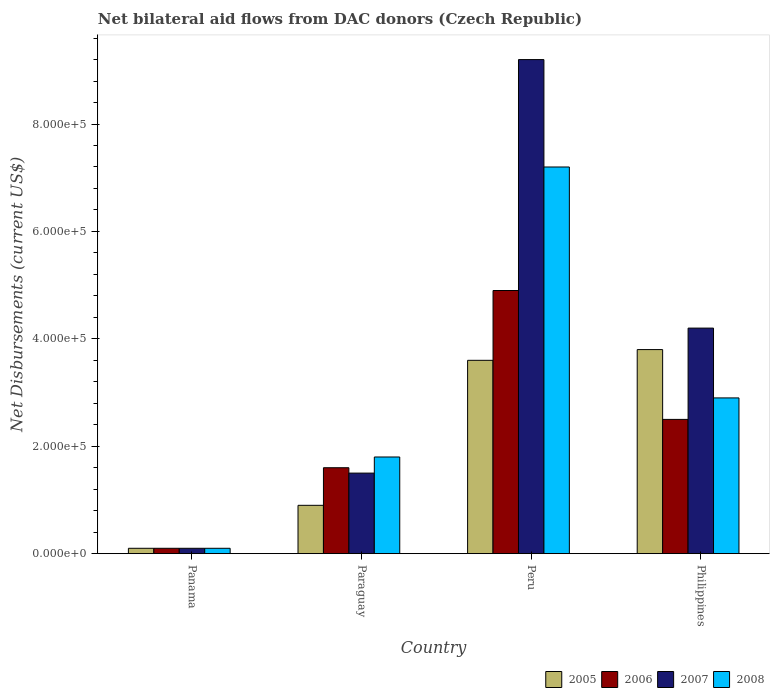How many groups of bars are there?
Give a very brief answer. 4. Are the number of bars per tick equal to the number of legend labels?
Your answer should be very brief. Yes. Are the number of bars on each tick of the X-axis equal?
Your answer should be very brief. Yes. How many bars are there on the 1st tick from the left?
Your answer should be very brief. 4. What is the label of the 3rd group of bars from the left?
Make the answer very short. Peru. In how many cases, is the number of bars for a given country not equal to the number of legend labels?
Offer a very short reply. 0. Across all countries, what is the maximum net bilateral aid flows in 2007?
Provide a succinct answer. 9.20e+05. In which country was the net bilateral aid flows in 2008 maximum?
Your answer should be compact. Peru. In which country was the net bilateral aid flows in 2007 minimum?
Offer a terse response. Panama. What is the total net bilateral aid flows in 2005 in the graph?
Ensure brevity in your answer.  8.40e+05. What is the difference between the net bilateral aid flows of/in 2006 and net bilateral aid flows of/in 2008 in Peru?
Your answer should be very brief. -2.30e+05. What is the ratio of the net bilateral aid flows in 2005 in Panama to that in Philippines?
Make the answer very short. 0.03. Is the difference between the net bilateral aid flows in 2006 in Panama and Philippines greater than the difference between the net bilateral aid flows in 2008 in Panama and Philippines?
Provide a succinct answer. Yes. What is the difference between the highest and the lowest net bilateral aid flows in 2008?
Your response must be concise. 7.10e+05. Is the sum of the net bilateral aid flows in 2005 in Peru and Philippines greater than the maximum net bilateral aid flows in 2008 across all countries?
Ensure brevity in your answer.  Yes. Is it the case that in every country, the sum of the net bilateral aid flows in 2005 and net bilateral aid flows in 2008 is greater than the sum of net bilateral aid flows in 2006 and net bilateral aid flows in 2007?
Your answer should be compact. No. What does the 1st bar from the left in Peru represents?
Provide a succinct answer. 2005. What does the 4th bar from the right in Philippines represents?
Your answer should be compact. 2005. How many bars are there?
Offer a very short reply. 16. Are all the bars in the graph horizontal?
Keep it short and to the point. No. How many countries are there in the graph?
Your answer should be compact. 4. Does the graph contain grids?
Provide a succinct answer. No. How many legend labels are there?
Offer a terse response. 4. How are the legend labels stacked?
Keep it short and to the point. Horizontal. What is the title of the graph?
Make the answer very short. Net bilateral aid flows from DAC donors (Czech Republic). Does "2006" appear as one of the legend labels in the graph?
Ensure brevity in your answer.  Yes. What is the label or title of the X-axis?
Provide a succinct answer. Country. What is the label or title of the Y-axis?
Provide a succinct answer. Net Disbursements (current US$). What is the Net Disbursements (current US$) of 2007 in Panama?
Make the answer very short. 10000. What is the Net Disbursements (current US$) of 2006 in Paraguay?
Offer a terse response. 1.60e+05. What is the Net Disbursements (current US$) in 2008 in Paraguay?
Give a very brief answer. 1.80e+05. What is the Net Disbursements (current US$) in 2007 in Peru?
Your answer should be very brief. 9.20e+05. What is the Net Disbursements (current US$) of 2008 in Peru?
Ensure brevity in your answer.  7.20e+05. What is the Net Disbursements (current US$) in 2005 in Philippines?
Make the answer very short. 3.80e+05. What is the Net Disbursements (current US$) in 2007 in Philippines?
Your response must be concise. 4.20e+05. Across all countries, what is the maximum Net Disbursements (current US$) in 2007?
Your answer should be compact. 9.20e+05. Across all countries, what is the maximum Net Disbursements (current US$) in 2008?
Your response must be concise. 7.20e+05. Across all countries, what is the minimum Net Disbursements (current US$) of 2006?
Make the answer very short. 10000. Across all countries, what is the minimum Net Disbursements (current US$) in 2008?
Give a very brief answer. 10000. What is the total Net Disbursements (current US$) in 2005 in the graph?
Your answer should be compact. 8.40e+05. What is the total Net Disbursements (current US$) of 2006 in the graph?
Ensure brevity in your answer.  9.10e+05. What is the total Net Disbursements (current US$) of 2007 in the graph?
Provide a short and direct response. 1.50e+06. What is the total Net Disbursements (current US$) of 2008 in the graph?
Offer a very short reply. 1.20e+06. What is the difference between the Net Disbursements (current US$) in 2005 in Panama and that in Paraguay?
Offer a terse response. -8.00e+04. What is the difference between the Net Disbursements (current US$) in 2006 in Panama and that in Paraguay?
Your answer should be compact. -1.50e+05. What is the difference between the Net Disbursements (current US$) in 2005 in Panama and that in Peru?
Your answer should be very brief. -3.50e+05. What is the difference between the Net Disbursements (current US$) in 2006 in Panama and that in Peru?
Your response must be concise. -4.80e+05. What is the difference between the Net Disbursements (current US$) in 2007 in Panama and that in Peru?
Your answer should be compact. -9.10e+05. What is the difference between the Net Disbursements (current US$) of 2008 in Panama and that in Peru?
Provide a short and direct response. -7.10e+05. What is the difference between the Net Disbursements (current US$) of 2005 in Panama and that in Philippines?
Offer a terse response. -3.70e+05. What is the difference between the Net Disbursements (current US$) in 2007 in Panama and that in Philippines?
Offer a very short reply. -4.10e+05. What is the difference between the Net Disbursements (current US$) of 2008 in Panama and that in Philippines?
Give a very brief answer. -2.80e+05. What is the difference between the Net Disbursements (current US$) in 2005 in Paraguay and that in Peru?
Offer a very short reply. -2.70e+05. What is the difference between the Net Disbursements (current US$) in 2006 in Paraguay and that in Peru?
Provide a succinct answer. -3.30e+05. What is the difference between the Net Disbursements (current US$) of 2007 in Paraguay and that in Peru?
Provide a succinct answer. -7.70e+05. What is the difference between the Net Disbursements (current US$) in 2008 in Paraguay and that in Peru?
Your answer should be compact. -5.40e+05. What is the difference between the Net Disbursements (current US$) in 2005 in Paraguay and that in Philippines?
Ensure brevity in your answer.  -2.90e+05. What is the difference between the Net Disbursements (current US$) in 2007 in Paraguay and that in Philippines?
Provide a succinct answer. -2.70e+05. What is the difference between the Net Disbursements (current US$) in 2008 in Paraguay and that in Philippines?
Keep it short and to the point. -1.10e+05. What is the difference between the Net Disbursements (current US$) of 2005 in Peru and that in Philippines?
Your answer should be compact. -2.00e+04. What is the difference between the Net Disbursements (current US$) of 2008 in Peru and that in Philippines?
Ensure brevity in your answer.  4.30e+05. What is the difference between the Net Disbursements (current US$) in 2005 in Panama and the Net Disbursements (current US$) in 2006 in Peru?
Provide a short and direct response. -4.80e+05. What is the difference between the Net Disbursements (current US$) in 2005 in Panama and the Net Disbursements (current US$) in 2007 in Peru?
Make the answer very short. -9.10e+05. What is the difference between the Net Disbursements (current US$) of 2005 in Panama and the Net Disbursements (current US$) of 2008 in Peru?
Your response must be concise. -7.10e+05. What is the difference between the Net Disbursements (current US$) in 2006 in Panama and the Net Disbursements (current US$) in 2007 in Peru?
Make the answer very short. -9.10e+05. What is the difference between the Net Disbursements (current US$) in 2006 in Panama and the Net Disbursements (current US$) in 2008 in Peru?
Give a very brief answer. -7.10e+05. What is the difference between the Net Disbursements (current US$) in 2007 in Panama and the Net Disbursements (current US$) in 2008 in Peru?
Your answer should be very brief. -7.10e+05. What is the difference between the Net Disbursements (current US$) of 2005 in Panama and the Net Disbursements (current US$) of 2006 in Philippines?
Your answer should be very brief. -2.40e+05. What is the difference between the Net Disbursements (current US$) of 2005 in Panama and the Net Disbursements (current US$) of 2007 in Philippines?
Make the answer very short. -4.10e+05. What is the difference between the Net Disbursements (current US$) of 2005 in Panama and the Net Disbursements (current US$) of 2008 in Philippines?
Provide a succinct answer. -2.80e+05. What is the difference between the Net Disbursements (current US$) of 2006 in Panama and the Net Disbursements (current US$) of 2007 in Philippines?
Make the answer very short. -4.10e+05. What is the difference between the Net Disbursements (current US$) of 2006 in Panama and the Net Disbursements (current US$) of 2008 in Philippines?
Keep it short and to the point. -2.80e+05. What is the difference between the Net Disbursements (current US$) in 2007 in Panama and the Net Disbursements (current US$) in 2008 in Philippines?
Provide a succinct answer. -2.80e+05. What is the difference between the Net Disbursements (current US$) in 2005 in Paraguay and the Net Disbursements (current US$) in 2006 in Peru?
Offer a very short reply. -4.00e+05. What is the difference between the Net Disbursements (current US$) in 2005 in Paraguay and the Net Disbursements (current US$) in 2007 in Peru?
Your answer should be compact. -8.30e+05. What is the difference between the Net Disbursements (current US$) in 2005 in Paraguay and the Net Disbursements (current US$) in 2008 in Peru?
Provide a short and direct response. -6.30e+05. What is the difference between the Net Disbursements (current US$) in 2006 in Paraguay and the Net Disbursements (current US$) in 2007 in Peru?
Give a very brief answer. -7.60e+05. What is the difference between the Net Disbursements (current US$) of 2006 in Paraguay and the Net Disbursements (current US$) of 2008 in Peru?
Your response must be concise. -5.60e+05. What is the difference between the Net Disbursements (current US$) in 2007 in Paraguay and the Net Disbursements (current US$) in 2008 in Peru?
Your answer should be compact. -5.70e+05. What is the difference between the Net Disbursements (current US$) of 2005 in Paraguay and the Net Disbursements (current US$) of 2007 in Philippines?
Offer a very short reply. -3.30e+05. What is the difference between the Net Disbursements (current US$) in 2006 in Paraguay and the Net Disbursements (current US$) in 2008 in Philippines?
Provide a succinct answer. -1.30e+05. What is the difference between the Net Disbursements (current US$) in 2007 in Paraguay and the Net Disbursements (current US$) in 2008 in Philippines?
Provide a succinct answer. -1.40e+05. What is the difference between the Net Disbursements (current US$) in 2006 in Peru and the Net Disbursements (current US$) in 2007 in Philippines?
Offer a terse response. 7.00e+04. What is the difference between the Net Disbursements (current US$) of 2007 in Peru and the Net Disbursements (current US$) of 2008 in Philippines?
Provide a succinct answer. 6.30e+05. What is the average Net Disbursements (current US$) in 2005 per country?
Your answer should be compact. 2.10e+05. What is the average Net Disbursements (current US$) of 2006 per country?
Your response must be concise. 2.28e+05. What is the average Net Disbursements (current US$) of 2007 per country?
Your answer should be compact. 3.75e+05. What is the average Net Disbursements (current US$) of 2008 per country?
Your answer should be very brief. 3.00e+05. What is the difference between the Net Disbursements (current US$) in 2005 and Net Disbursements (current US$) in 2006 in Panama?
Give a very brief answer. 0. What is the difference between the Net Disbursements (current US$) in 2005 and Net Disbursements (current US$) in 2008 in Panama?
Your answer should be compact. 0. What is the difference between the Net Disbursements (current US$) of 2006 and Net Disbursements (current US$) of 2008 in Panama?
Provide a succinct answer. 0. What is the difference between the Net Disbursements (current US$) of 2005 and Net Disbursements (current US$) of 2006 in Paraguay?
Your answer should be very brief. -7.00e+04. What is the difference between the Net Disbursements (current US$) in 2005 and Net Disbursements (current US$) in 2007 in Paraguay?
Give a very brief answer. -6.00e+04. What is the difference between the Net Disbursements (current US$) of 2006 and Net Disbursements (current US$) of 2008 in Paraguay?
Your answer should be compact. -2.00e+04. What is the difference between the Net Disbursements (current US$) in 2005 and Net Disbursements (current US$) in 2007 in Peru?
Offer a terse response. -5.60e+05. What is the difference between the Net Disbursements (current US$) in 2005 and Net Disbursements (current US$) in 2008 in Peru?
Provide a short and direct response. -3.60e+05. What is the difference between the Net Disbursements (current US$) in 2006 and Net Disbursements (current US$) in 2007 in Peru?
Your answer should be compact. -4.30e+05. What is the difference between the Net Disbursements (current US$) of 2007 and Net Disbursements (current US$) of 2008 in Peru?
Give a very brief answer. 2.00e+05. What is the difference between the Net Disbursements (current US$) of 2005 and Net Disbursements (current US$) of 2006 in Philippines?
Your response must be concise. 1.30e+05. What is the difference between the Net Disbursements (current US$) in 2005 and Net Disbursements (current US$) in 2007 in Philippines?
Your answer should be compact. -4.00e+04. What is the difference between the Net Disbursements (current US$) in 2006 and Net Disbursements (current US$) in 2007 in Philippines?
Offer a terse response. -1.70e+05. What is the ratio of the Net Disbursements (current US$) of 2005 in Panama to that in Paraguay?
Offer a terse response. 0.11. What is the ratio of the Net Disbursements (current US$) of 2006 in Panama to that in Paraguay?
Give a very brief answer. 0.06. What is the ratio of the Net Disbursements (current US$) in 2007 in Panama to that in Paraguay?
Your answer should be compact. 0.07. What is the ratio of the Net Disbursements (current US$) of 2008 in Panama to that in Paraguay?
Give a very brief answer. 0.06. What is the ratio of the Net Disbursements (current US$) in 2005 in Panama to that in Peru?
Your answer should be very brief. 0.03. What is the ratio of the Net Disbursements (current US$) in 2006 in Panama to that in Peru?
Offer a terse response. 0.02. What is the ratio of the Net Disbursements (current US$) in 2007 in Panama to that in Peru?
Your response must be concise. 0.01. What is the ratio of the Net Disbursements (current US$) of 2008 in Panama to that in Peru?
Make the answer very short. 0.01. What is the ratio of the Net Disbursements (current US$) in 2005 in Panama to that in Philippines?
Ensure brevity in your answer.  0.03. What is the ratio of the Net Disbursements (current US$) in 2007 in Panama to that in Philippines?
Provide a short and direct response. 0.02. What is the ratio of the Net Disbursements (current US$) in 2008 in Panama to that in Philippines?
Ensure brevity in your answer.  0.03. What is the ratio of the Net Disbursements (current US$) in 2006 in Paraguay to that in Peru?
Keep it short and to the point. 0.33. What is the ratio of the Net Disbursements (current US$) in 2007 in Paraguay to that in Peru?
Make the answer very short. 0.16. What is the ratio of the Net Disbursements (current US$) of 2008 in Paraguay to that in Peru?
Keep it short and to the point. 0.25. What is the ratio of the Net Disbursements (current US$) of 2005 in Paraguay to that in Philippines?
Ensure brevity in your answer.  0.24. What is the ratio of the Net Disbursements (current US$) in 2006 in Paraguay to that in Philippines?
Provide a succinct answer. 0.64. What is the ratio of the Net Disbursements (current US$) in 2007 in Paraguay to that in Philippines?
Offer a terse response. 0.36. What is the ratio of the Net Disbursements (current US$) in 2008 in Paraguay to that in Philippines?
Provide a short and direct response. 0.62. What is the ratio of the Net Disbursements (current US$) in 2006 in Peru to that in Philippines?
Keep it short and to the point. 1.96. What is the ratio of the Net Disbursements (current US$) in 2007 in Peru to that in Philippines?
Keep it short and to the point. 2.19. What is the ratio of the Net Disbursements (current US$) of 2008 in Peru to that in Philippines?
Make the answer very short. 2.48. What is the difference between the highest and the second highest Net Disbursements (current US$) in 2005?
Make the answer very short. 2.00e+04. What is the difference between the highest and the second highest Net Disbursements (current US$) of 2006?
Make the answer very short. 2.40e+05. What is the difference between the highest and the lowest Net Disbursements (current US$) of 2005?
Give a very brief answer. 3.70e+05. What is the difference between the highest and the lowest Net Disbursements (current US$) in 2007?
Your response must be concise. 9.10e+05. What is the difference between the highest and the lowest Net Disbursements (current US$) in 2008?
Provide a succinct answer. 7.10e+05. 